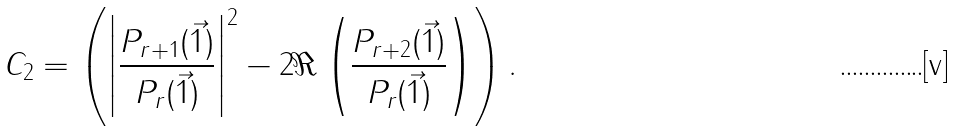Convert formula to latex. <formula><loc_0><loc_0><loc_500><loc_500>C _ { 2 } = \left ( \left | \frac { P _ { r + 1 } ( \vec { 1 } ) } { P _ { r } ( \vec { 1 } ) } \right | ^ { 2 } - 2 \Re \left ( \frac { P _ { r + 2 } ( \vec { 1 } ) } { P _ { r } ( \vec { 1 } ) } \right ) \right ) .</formula> 